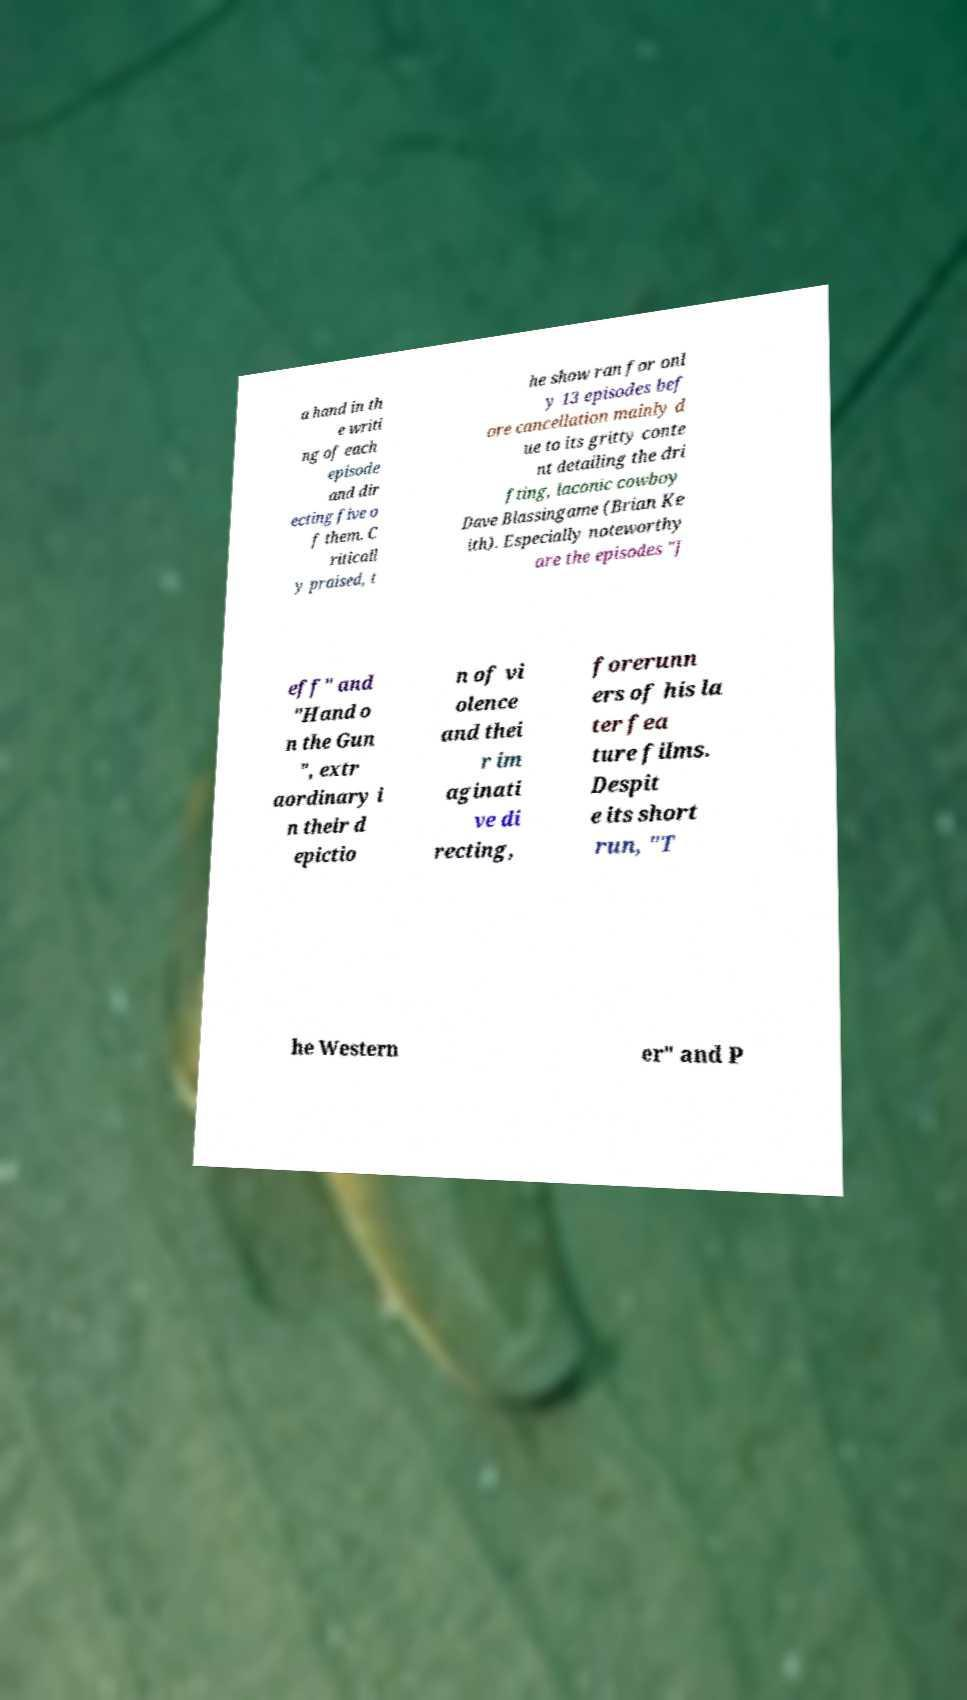Could you extract and type out the text from this image? a hand in th e writi ng of each episode and dir ecting five o f them. C riticall y praised, t he show ran for onl y 13 episodes bef ore cancellation mainly d ue to its gritty conte nt detailing the dri fting, laconic cowboy Dave Blassingame (Brian Ke ith). Especially noteworthy are the episodes "J eff" and "Hand o n the Gun ", extr aordinary i n their d epictio n of vi olence and thei r im aginati ve di recting, forerunn ers of his la ter fea ture films. Despit e its short run, "T he Western er" and P 